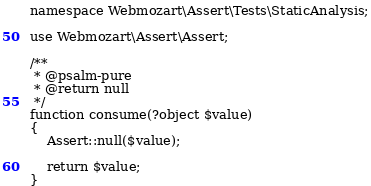<code> <loc_0><loc_0><loc_500><loc_500><_PHP_>
namespace Webmozart\Assert\Tests\StaticAnalysis;

use Webmozart\Assert\Assert;

/**
 * @psalm-pure
 * @return null
 */
function consume(?object $value)
{
    Assert::null($value);

    return $value;
}
</code> 